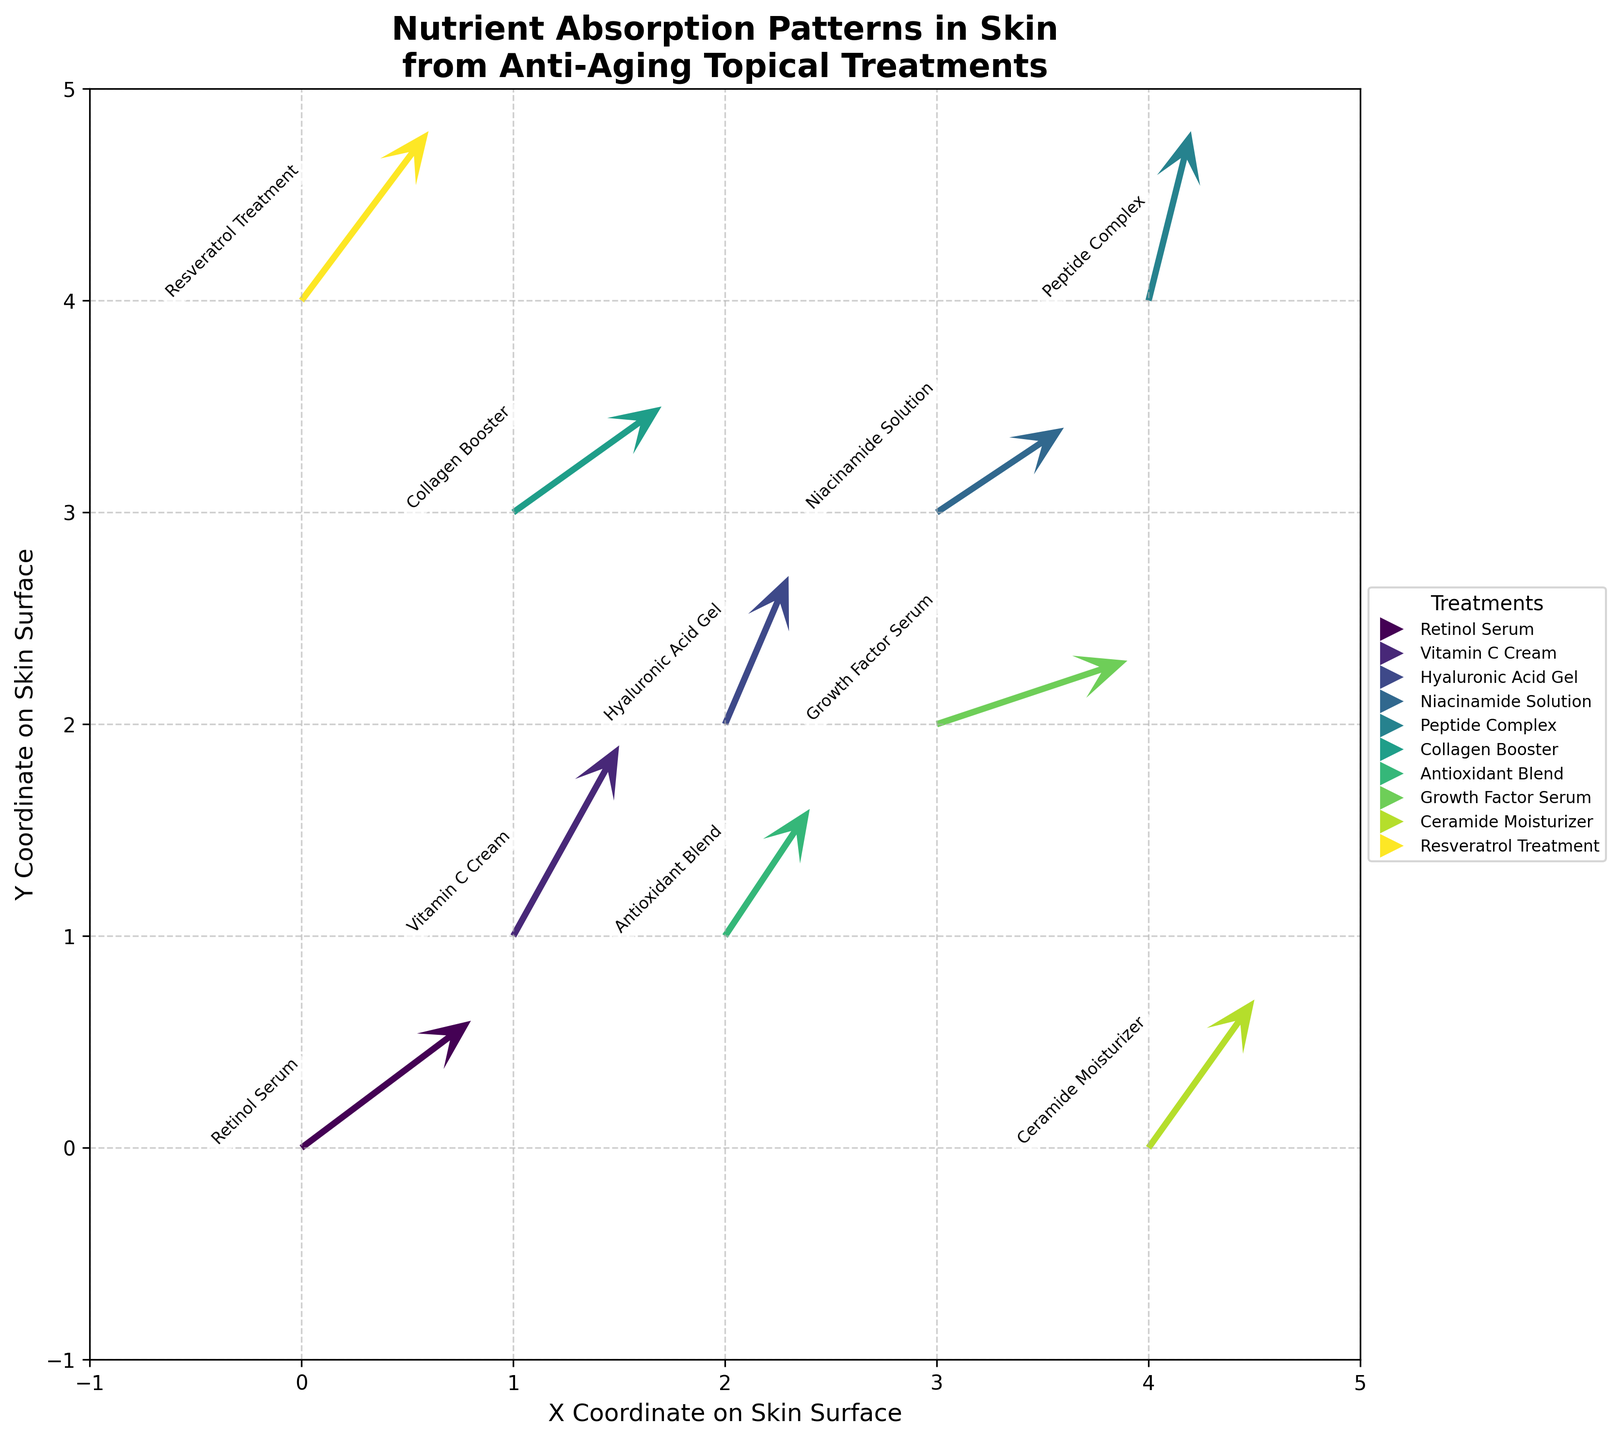Which treatment shows the highest upward absorption vector? The highest upward absorption vector corresponds to the largest value of the 'V' component. In our data, Vitamin C Cream has the highest V value of 0.9.
Answer: Vitamin C Cream What is the title of the figure? The title is located at the top of the figure, usually in a larger or bold font.
Answer: Nutrient Absorption Patterns in Skin from Anti-Aging Topical Treatments Which treatment is represented at the coordinates (3, 2)? You can find this by locating the value of (3, 2) in the X and Y columns and then checking its corresponding treatment. Growth Factor Serum is at (3, 2).
Answer: Growth Factor Serum How many treatments are plotted in the figure? Count the unique treatments listed in the data. There are 10 unique treatments provided.
Answer: 10 Which treatment has the smallest horizontal vector component? The smallest horizontal vector component corresponds to the smallest value of 'U'. In our data, Peptide Complex has the smallest value of U which is 0.2.
Answer: Peptide Complex Which two treatments have vector directions most similar to each other? Two treatments would have similar vector directions if their (U, V) components are close to each other. Comparing the vectors, Retinol Serum (0.8, 0.6) and Collagen Booster (0.7, 0.5) have very similar directions.
Answer: Retinol Serum and Collagen Booster Is there any treatment that has both U and V components equal to 0.5? Check the U and V columns to see if any row has both values equal to 0.5. None of the treatments have both U and V equal to 0.5.
Answer: No Which axis—X or Y—has a limiting range between -1 and 5? Both axes should have their range visible from the figure itself, which usually shows the min and max tick marks along the axis lines. Both X and Y axes have a range from -1 to 5.
Answer: Both Which quadrant contains treatments with predominantly downward vectors? Downward vectors would have negative V components. By inspecting the V values, we find Growth Factor Serum (3, 2) and Niacinamide Solution (3, 3) are predominantly downward vectors located in the fourth quadrant for Growth Factor Serum and third quadrant for Niacinamide Solution.
Answer: Quadrant III and IV 